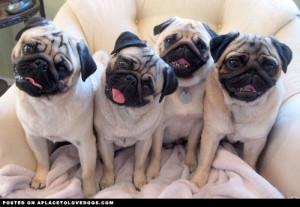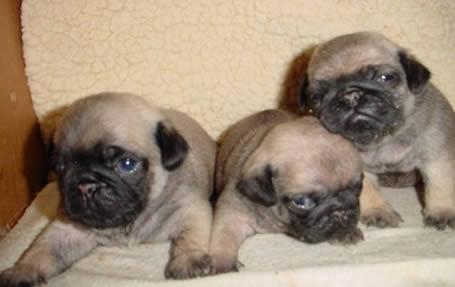The first image is the image on the left, the second image is the image on the right. Examine the images to the left and right. Is the description "There is two pugs in the right image." accurate? Answer yes or no. No. The first image is the image on the left, the second image is the image on the right. Evaluate the accuracy of this statement regarding the images: "There are two puppies visible in the image on the right". Is it true? Answer yes or no. No. 